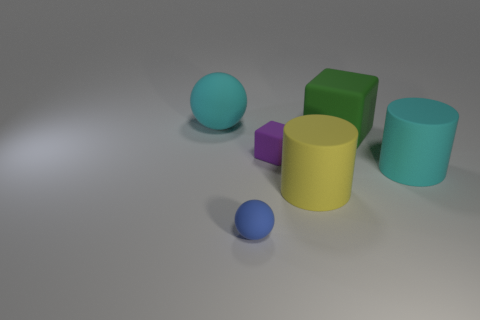How many objects are either tiny blue balls that are in front of the green cube or cyan objects to the left of the small blue thing?
Offer a very short reply. 2. There is a cyan object to the left of the large cyan object that is in front of the big cyan object left of the small purple thing; what size is it?
Ensure brevity in your answer.  Large. Are there the same number of blue rubber spheres that are to the left of the tiny sphere and yellow cylinders?
Ensure brevity in your answer.  No. Do the purple matte object and the large cyan thing that is in front of the cyan matte ball have the same shape?
Provide a short and direct response. No. What size is the other object that is the same shape as the big green matte thing?
Your response must be concise. Small. What number of other things are there of the same material as the tiny ball
Keep it short and to the point. 5. There is a big object to the left of the small purple cube; does it have the same color as the cylinder that is behind the large yellow thing?
Your answer should be compact. Yes. Are there more large cyan matte things to the left of the small purple rubber cube than big gray matte cylinders?
Offer a very short reply. Yes. How many other things are the same color as the big ball?
Your answer should be compact. 1. Do the cube that is on the right side of the purple rubber block and the small sphere have the same size?
Keep it short and to the point. No. 